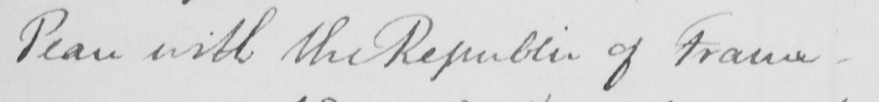What does this handwritten line say? Peace with the Republic of France  _ 